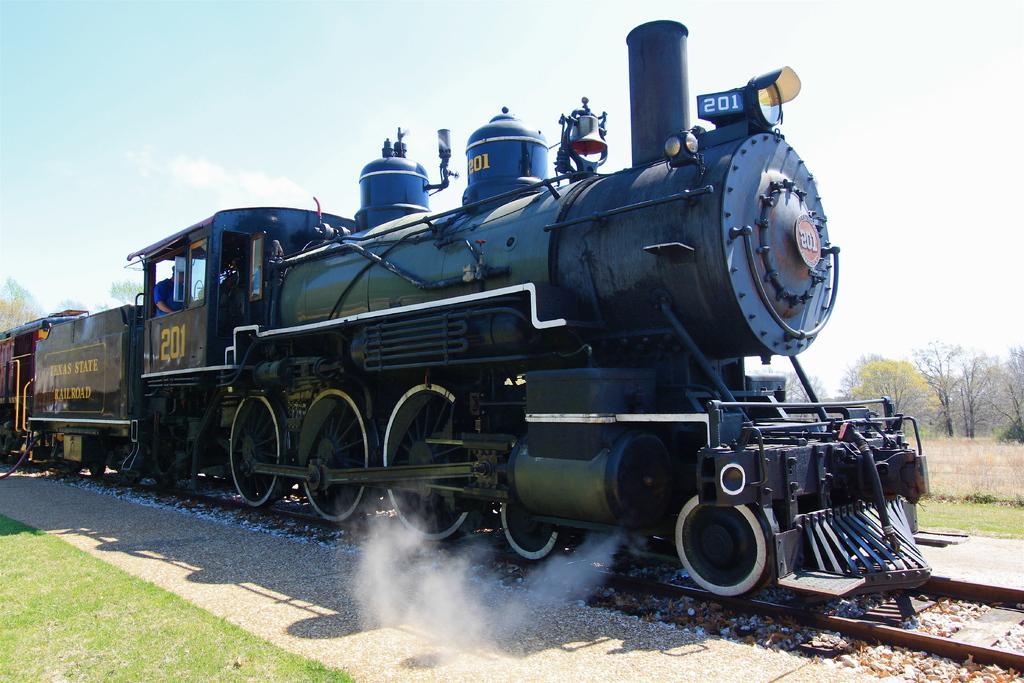Please provide a concise description of this image. As we can see in the image there is a train, railway track, grass and trees. On the top there is sky. 